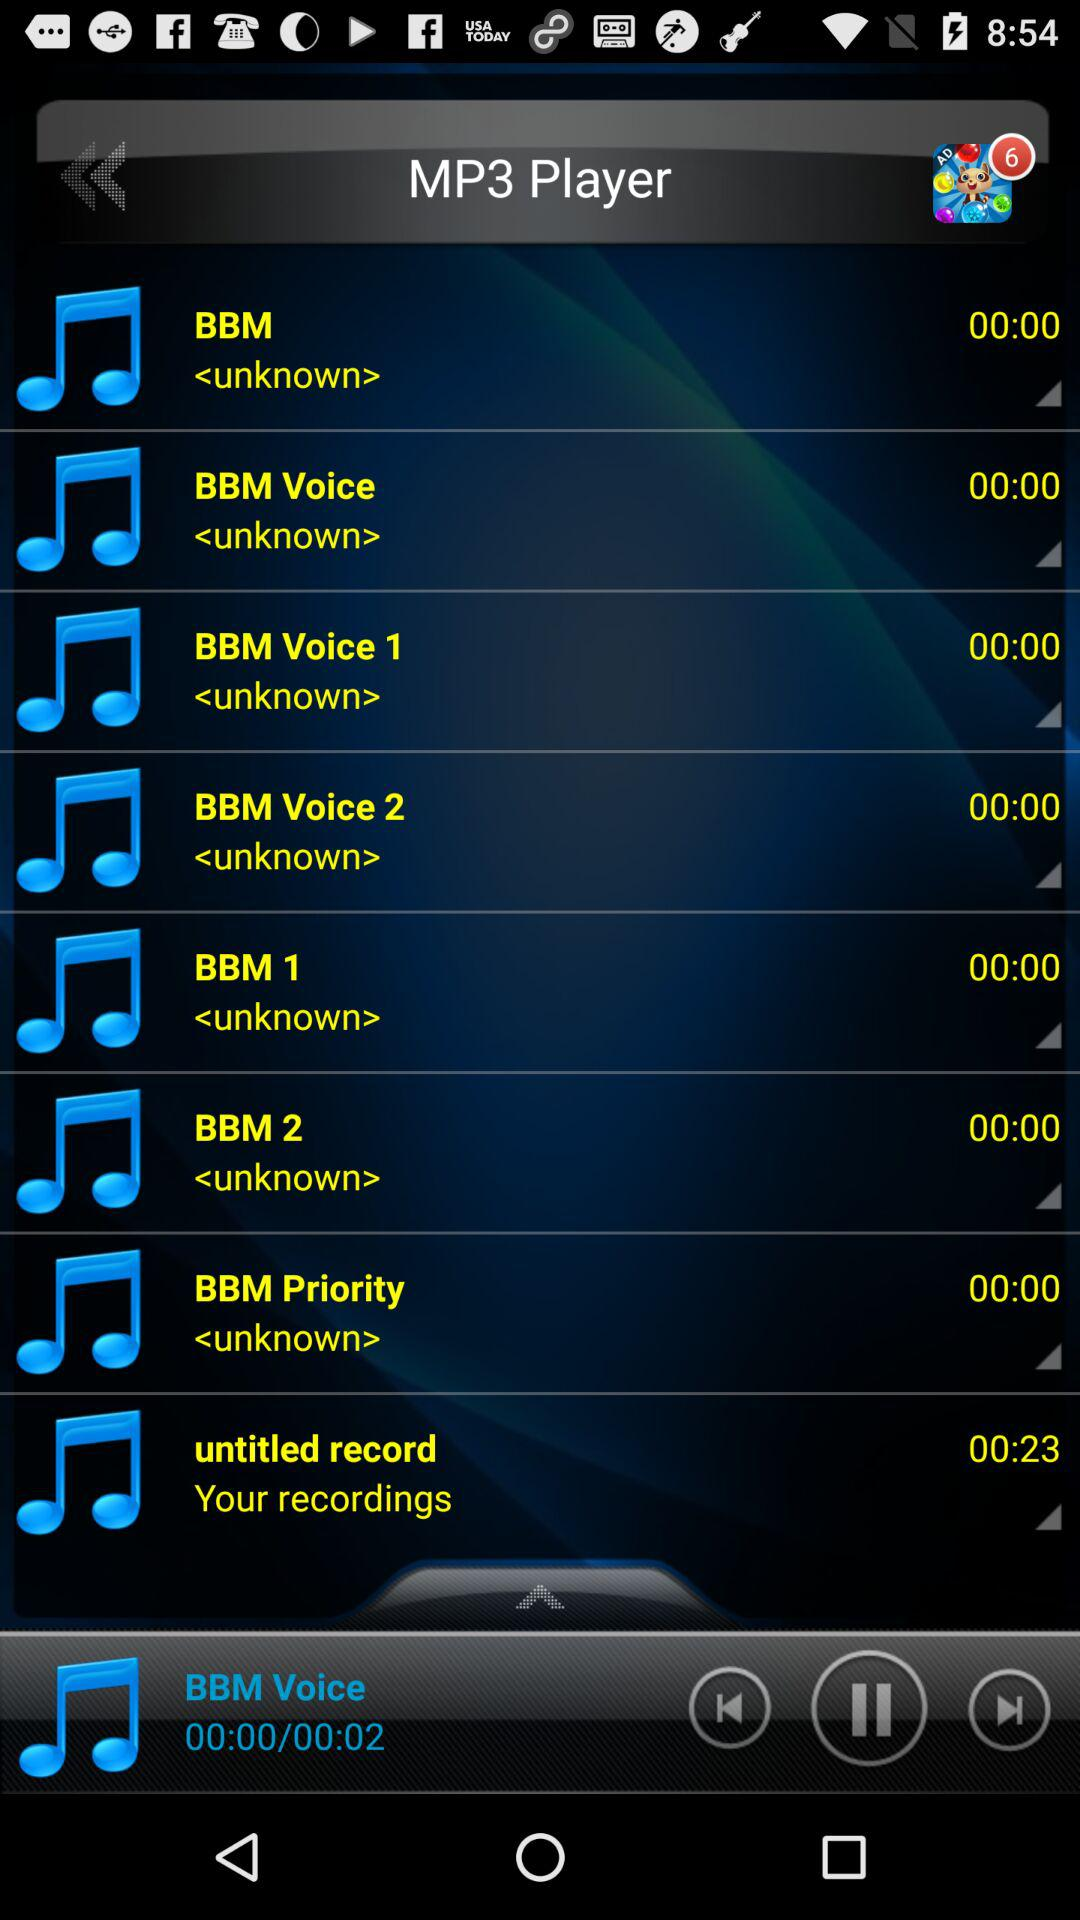How many notifications have been shown? The shown notifications are 6. 